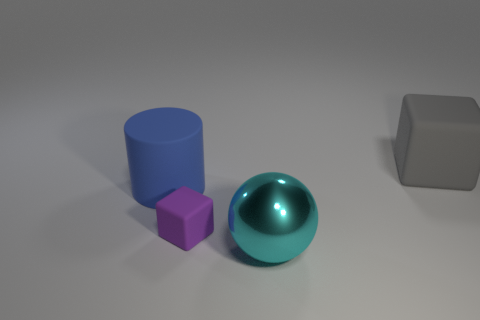Add 4 big yellow matte cylinders. How many objects exist? 8 Subtract 1 blocks. How many blocks are left? 1 Subtract all tiny purple matte cubes. Subtract all metallic balls. How many objects are left? 2 Add 1 tiny matte things. How many tiny matte things are left? 2 Add 3 green balls. How many green balls exist? 3 Subtract 0 blue cubes. How many objects are left? 4 Subtract all cylinders. How many objects are left? 3 Subtract all brown balls. Subtract all green cylinders. How many balls are left? 1 Subtract all yellow cylinders. How many gray blocks are left? 1 